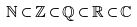<formula> <loc_0><loc_0><loc_500><loc_500>\mathbb { N } \subset \mathbb { Z } \subset \mathbb { Q } \subset \mathbb { R } \subset \mathbb { C }</formula> 